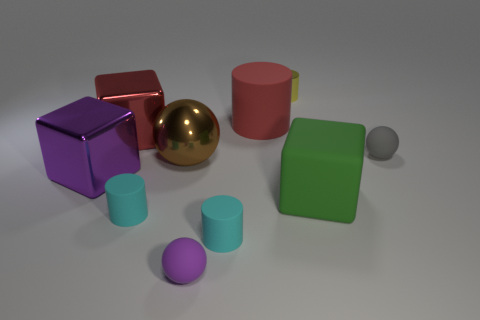Subtract all shiny blocks. How many blocks are left? 1 Subtract all green cubes. How many cubes are left? 2 Subtract 2 cubes. How many cubes are left? 1 Subtract all cubes. How many objects are left? 7 Subtract all gray cylinders. How many gray blocks are left? 0 Subtract all blue objects. Subtract all rubber balls. How many objects are left? 8 Add 5 large brown metal things. How many large brown metal things are left? 6 Add 9 big brown shiny cylinders. How many big brown shiny cylinders exist? 9 Subtract 0 green cylinders. How many objects are left? 10 Subtract all red blocks. Subtract all purple cylinders. How many blocks are left? 2 